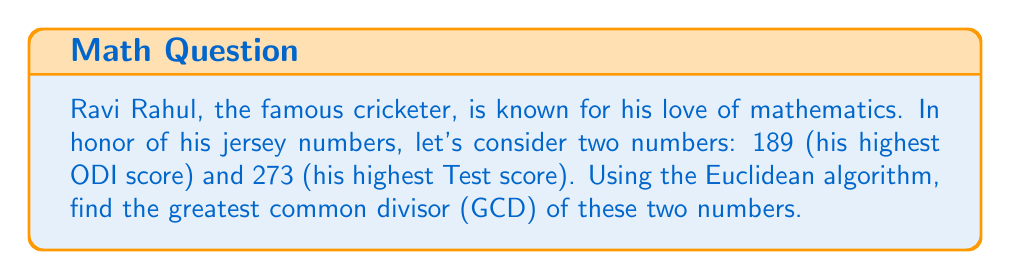Teach me how to tackle this problem. To find the GCD of 189 and 273 using the Euclidean algorithm, we follow these steps:

1) First, we set up the initial equation:
   $273 = 1 \times 189 + 84$

2) We then use the remainder (84) and divide the previous divisor (189) by it:
   $189 = 2 \times 84 + 21$

3) We continue this process:
   $84 = 4 \times 21 + 0$

4) The process stops when we get a remainder of 0.

The last non-zero remainder is the GCD. Let's represent this process mathematically:

$$\begin{align}
273 &= 1 \times 189 + 84 \\
189 &= 2 \times 84 + 21 \\
84 &= 4 \times 21 + 0
\end{align}$$

Therefore, the GCD of 189 and 273 is 21.

We can verify this result:
$189 = 9 \times 21$
$273 = 13 \times 21$

Indeed, 21 is the largest number that divides both 189 and 273 without leaving a remainder.
Answer: The greatest common divisor of 189 and 273 is 21. 